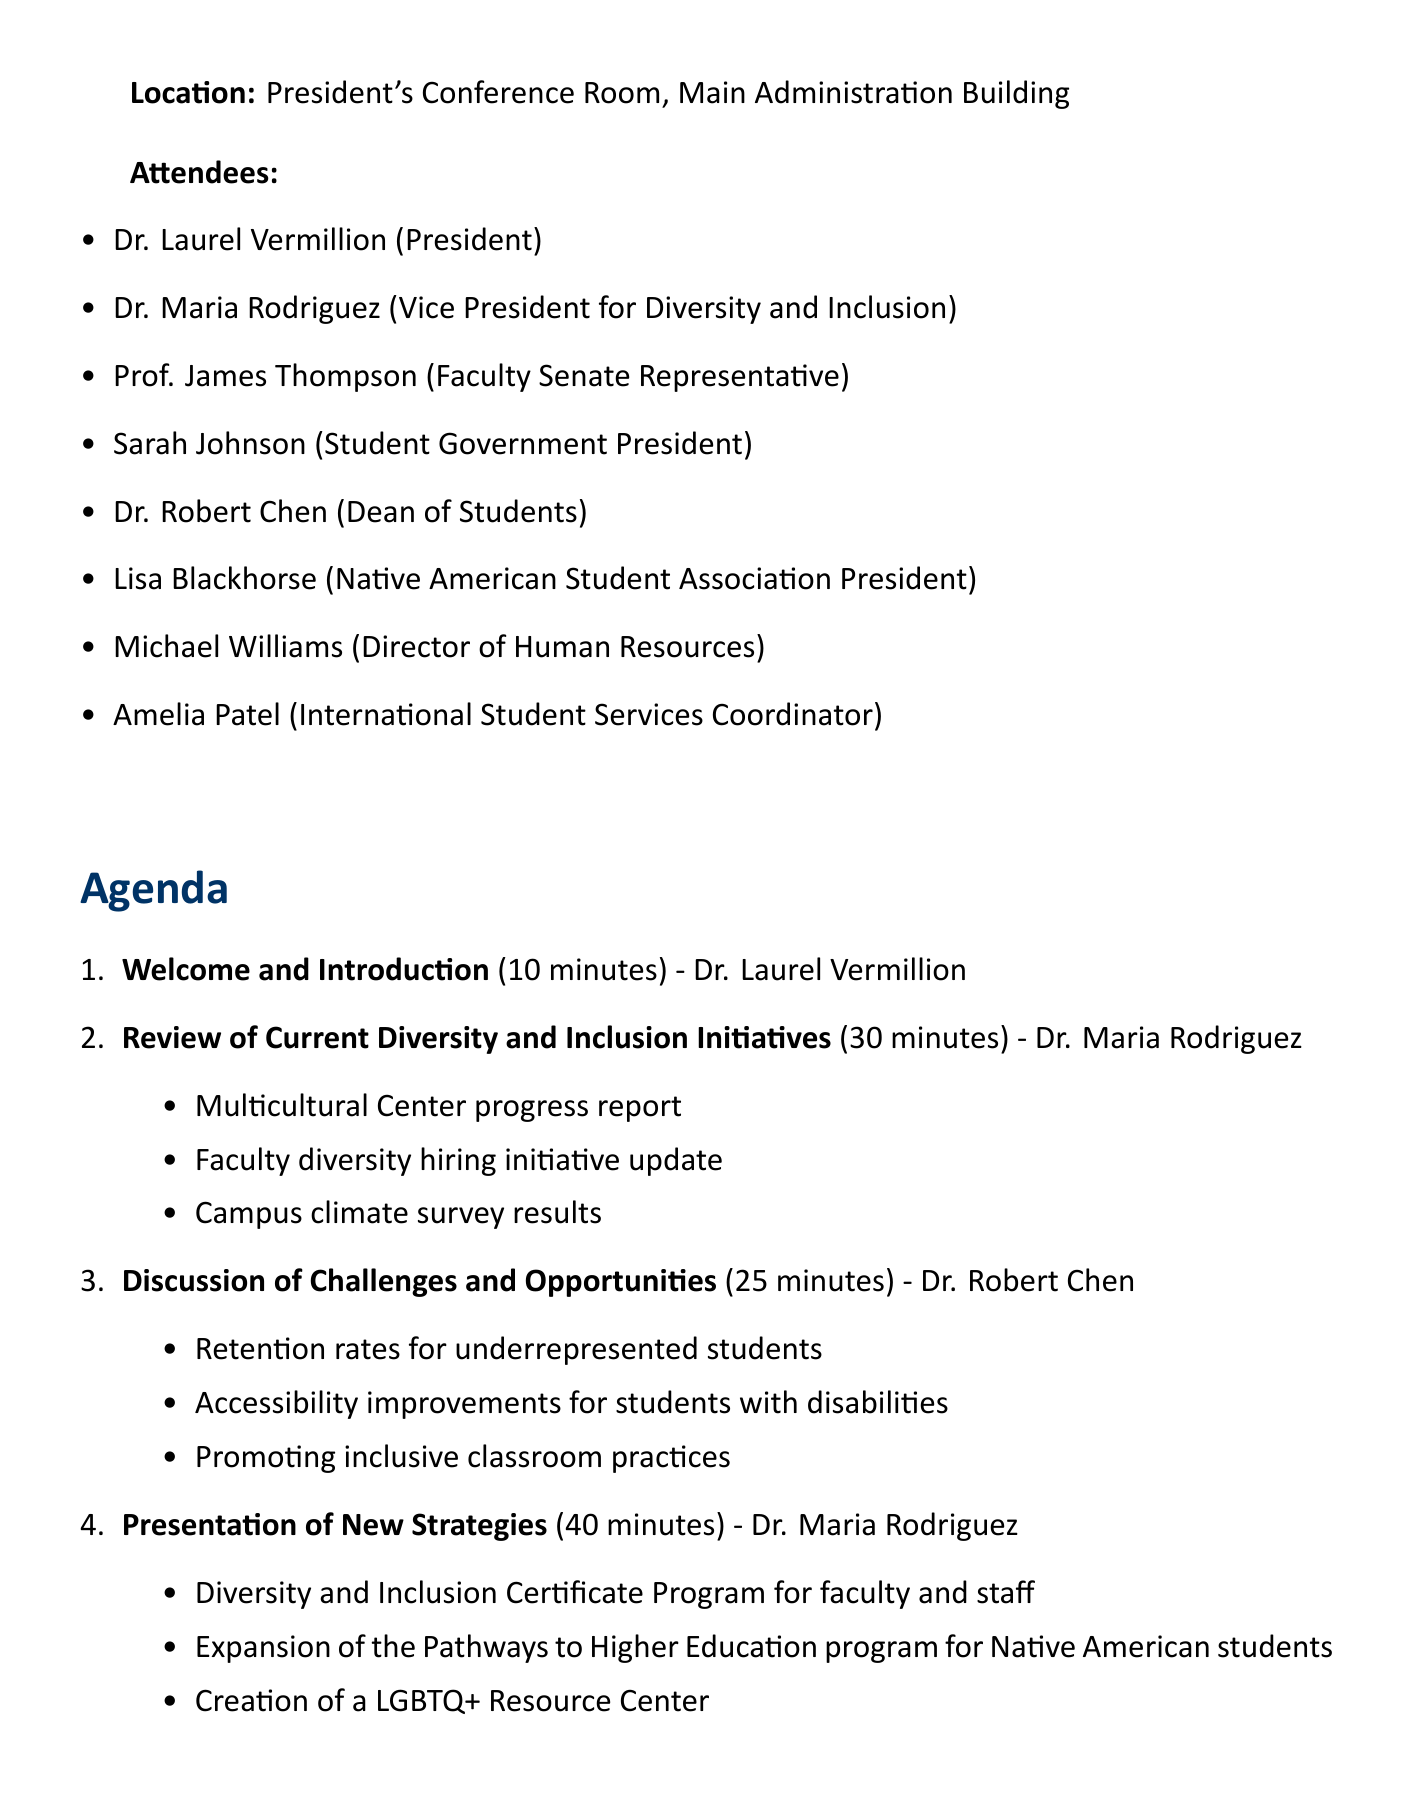What is the date of the meeting? The date of the meeting is specified in the document as May 15, 2023.
Answer: May 15, 2023 Who will present the review of current diversity initiatives? The presenter for the review of current initiatives is mentioned in the document as Dr. Maria Rodriguez.
Answer: Dr. Maria Rodriguez How long is the presentation of new strategies scheduled for? The document states that the presentation of new strategies is allotted 40 minutes in duration.
Answer: 40 minutes What is one of the proposed initiatives for campus-wide implementation? One proposed initiative included in the document is the Diversity and Inclusion Certificate Program for faculty and staff.
Answer: Diversity and Inclusion Certificate Program for faculty and staff What are the key performance indicators related to faculty diversity representation? The document indicates a goal of achieving 25% faculty diversity representation within five years.
Answer: 25% faculty diversity representation Which item will be discussed for 25 minutes? The document specifies that the "Discussion of Challenges and Opportunities" will take 25 minutes.
Answer: Discussion of Challenges and Opportunities How often will the task force meet to follow up on action items? The document does not specify a recurrence of meetings but notes action items and next steps to be discussed.
Answer: Not specified What is the location of the meeting? The location of the meeting is described as the President's Conference Room, Main Administration Building.
Answer: President's Conference Room, Main Administration Building Who is responsible for facilitating the feedback discussion? The facilitator for the group discussion and feedback is identified as Prof. James Thompson in the document.
Answer: Prof. James Thompson 